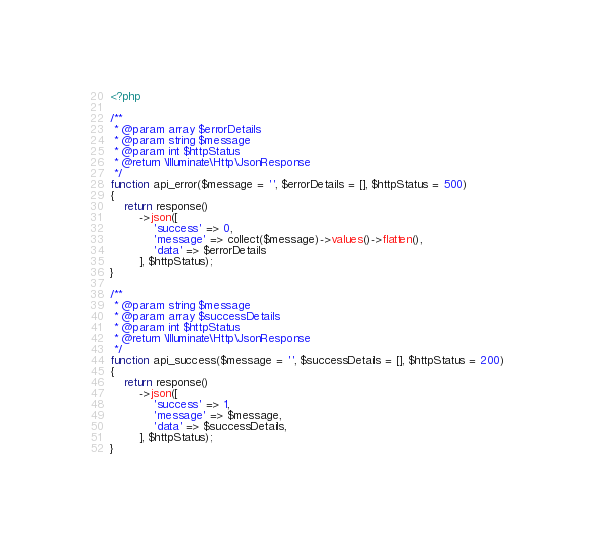<code> <loc_0><loc_0><loc_500><loc_500><_PHP_><?php

/**
 * @param array $errorDetails
 * @param string $message
 * @param int $httpStatus
 * @return \Illuminate\Http\JsonResponse
 */
function api_error($message = '', $errorDetails = [], $httpStatus = 500)
{
    return response()
        ->json([
            'success' => 0,
            'message' => collect($message)->values()->flatten(),
            'data' => $errorDetails
        ], $httpStatus);
}

/**
 * @param string $message
 * @param array $successDetails
 * @param int $httpStatus
 * @return \Illuminate\Http\JsonResponse
 */
function api_success($message = '', $successDetails = [], $httpStatus = 200)
{
    return response()
        ->json([
            'success' => 1,
            'message' => $message,
            'data' => $successDetails,
        ], $httpStatus);
}</code> 